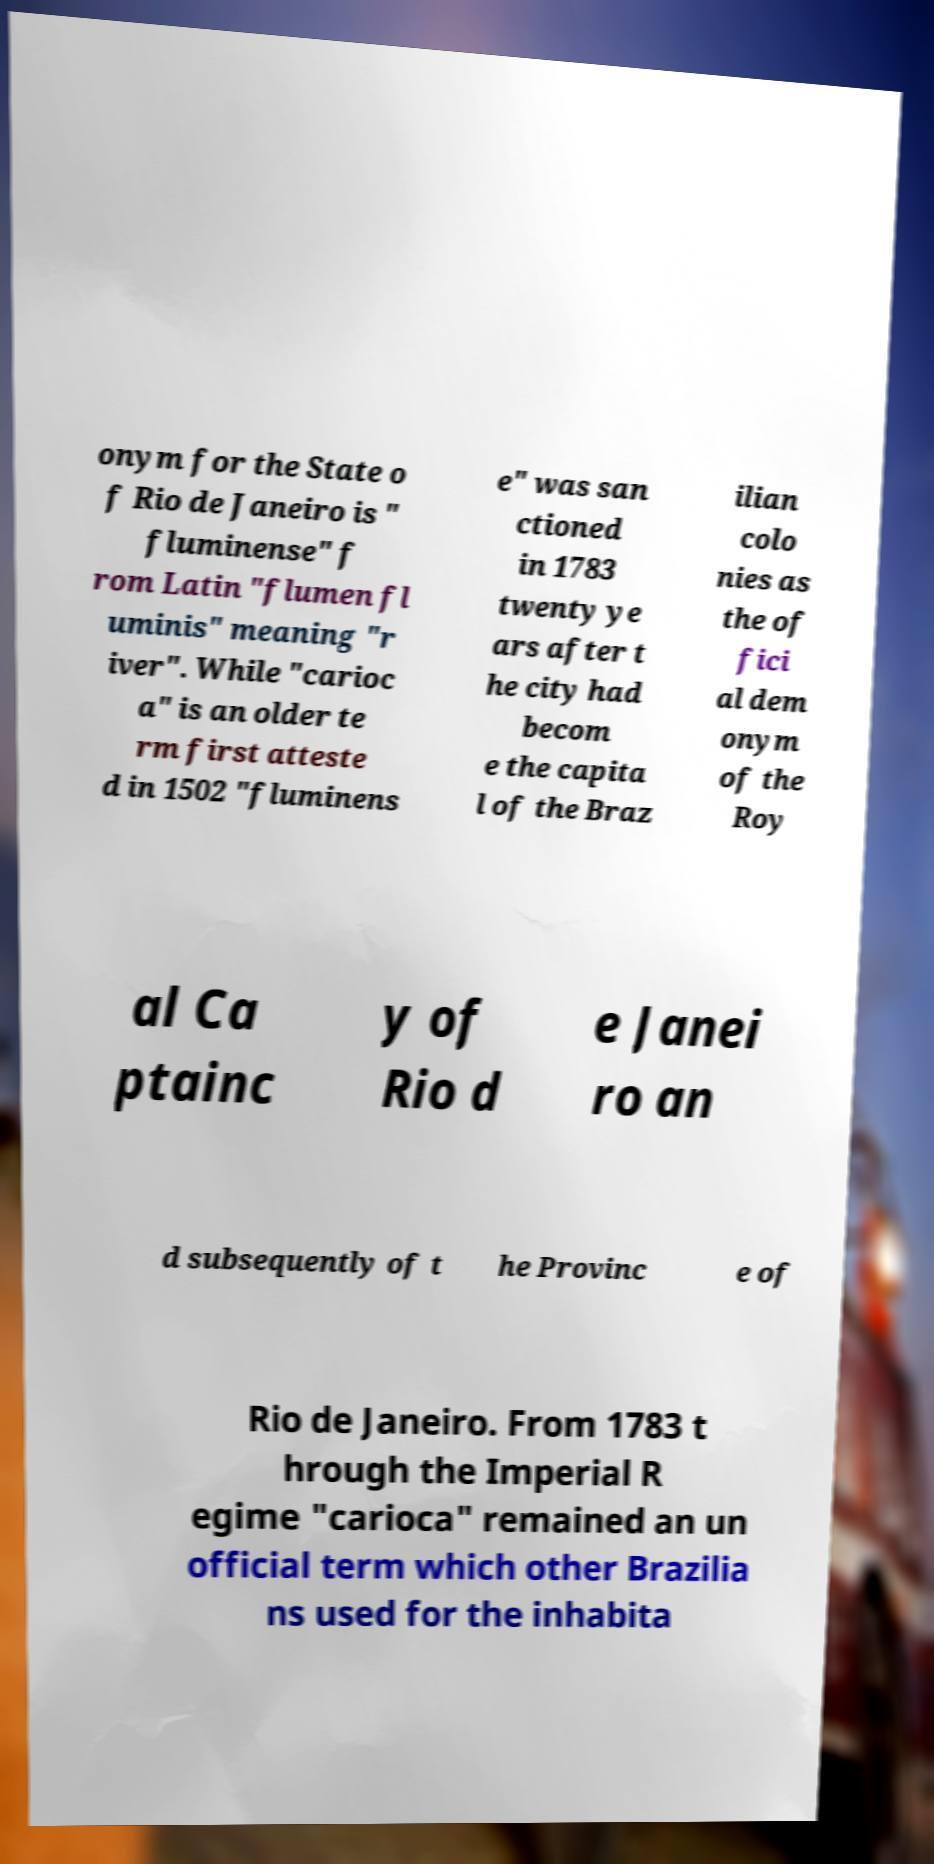There's text embedded in this image that I need extracted. Can you transcribe it verbatim? onym for the State o f Rio de Janeiro is " fluminense" f rom Latin "flumen fl uminis" meaning "r iver". While "carioc a" is an older te rm first atteste d in 1502 "fluminens e" was san ctioned in 1783 twenty ye ars after t he city had becom e the capita l of the Braz ilian colo nies as the of fici al dem onym of the Roy al Ca ptainc y of Rio d e Janei ro an d subsequently of t he Provinc e of Rio de Janeiro. From 1783 t hrough the Imperial R egime "carioca" remained an un official term which other Brazilia ns used for the inhabita 